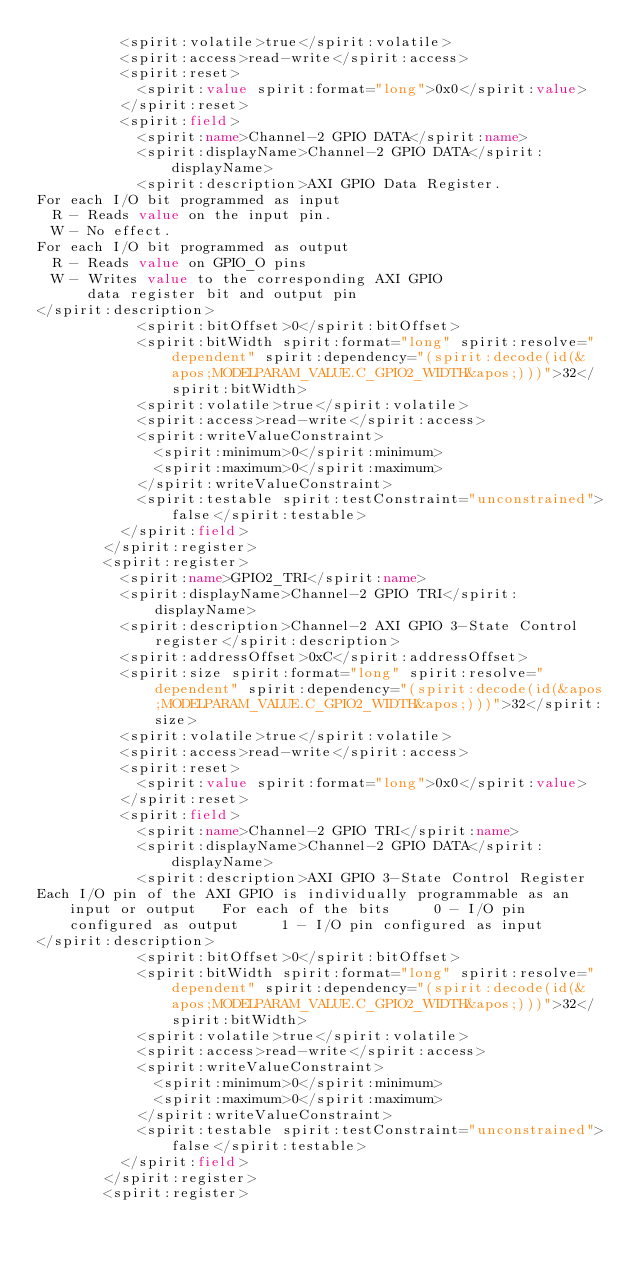Convert code to text. <code><loc_0><loc_0><loc_500><loc_500><_XML_>          <spirit:volatile>true</spirit:volatile>
          <spirit:access>read-write</spirit:access>
          <spirit:reset>
            <spirit:value spirit:format="long">0x0</spirit:value>
          </spirit:reset>
          <spirit:field>
            <spirit:name>Channel-2 GPIO DATA</spirit:name>
            <spirit:displayName>Channel-2 GPIO DATA</spirit:displayName>
            <spirit:description>AXI GPIO Data Register.
For each I/O bit programmed as input
  R - Reads value on the input pin.
  W - No effect.
For each I/O bit programmed as output
  R - Reads value on GPIO_O pins
  W - Writes value to the corresponding AXI GPIO 
      data register bit and output pin
</spirit:description>
            <spirit:bitOffset>0</spirit:bitOffset>
            <spirit:bitWidth spirit:format="long" spirit:resolve="dependent" spirit:dependency="(spirit:decode(id(&apos;MODELPARAM_VALUE.C_GPIO2_WIDTH&apos;)))">32</spirit:bitWidth>
            <spirit:volatile>true</spirit:volatile>
            <spirit:access>read-write</spirit:access>
            <spirit:writeValueConstraint>
              <spirit:minimum>0</spirit:minimum>
              <spirit:maximum>0</spirit:maximum>
            </spirit:writeValueConstraint>
            <spirit:testable spirit:testConstraint="unconstrained">false</spirit:testable>
          </spirit:field>
        </spirit:register>
        <spirit:register>
          <spirit:name>GPIO2_TRI</spirit:name>
          <spirit:displayName>Channel-2 GPIO TRI</spirit:displayName>
          <spirit:description>Channel-2 AXI GPIO 3-State Control register</spirit:description>
          <spirit:addressOffset>0xC</spirit:addressOffset>
          <spirit:size spirit:format="long" spirit:resolve="dependent" spirit:dependency="(spirit:decode(id(&apos;MODELPARAM_VALUE.C_GPIO2_WIDTH&apos;)))">32</spirit:size>
          <spirit:volatile>true</spirit:volatile>
          <spirit:access>read-write</spirit:access>
          <spirit:reset>
            <spirit:value spirit:format="long">0x0</spirit:value>
          </spirit:reset>
          <spirit:field>
            <spirit:name>Channel-2 GPIO TRI</spirit:name>
            <spirit:displayName>Channel-2 GPIO DATA</spirit:displayName>
            <spirit:description>AXI GPIO 3-State Control Register
Each I/O pin of the AXI GPIO is individually programmable as an input or output   For each of the bits     0 - I/O pin configured as output     1 - I/O pin configured as input
</spirit:description>
            <spirit:bitOffset>0</spirit:bitOffset>
            <spirit:bitWidth spirit:format="long" spirit:resolve="dependent" spirit:dependency="(spirit:decode(id(&apos;MODELPARAM_VALUE.C_GPIO2_WIDTH&apos;)))">32</spirit:bitWidth>
            <spirit:volatile>true</spirit:volatile>
            <spirit:access>read-write</spirit:access>
            <spirit:writeValueConstraint>
              <spirit:minimum>0</spirit:minimum>
              <spirit:maximum>0</spirit:maximum>
            </spirit:writeValueConstraint>
            <spirit:testable spirit:testConstraint="unconstrained">false</spirit:testable>
          </spirit:field>
        </spirit:register>
        <spirit:register></code> 